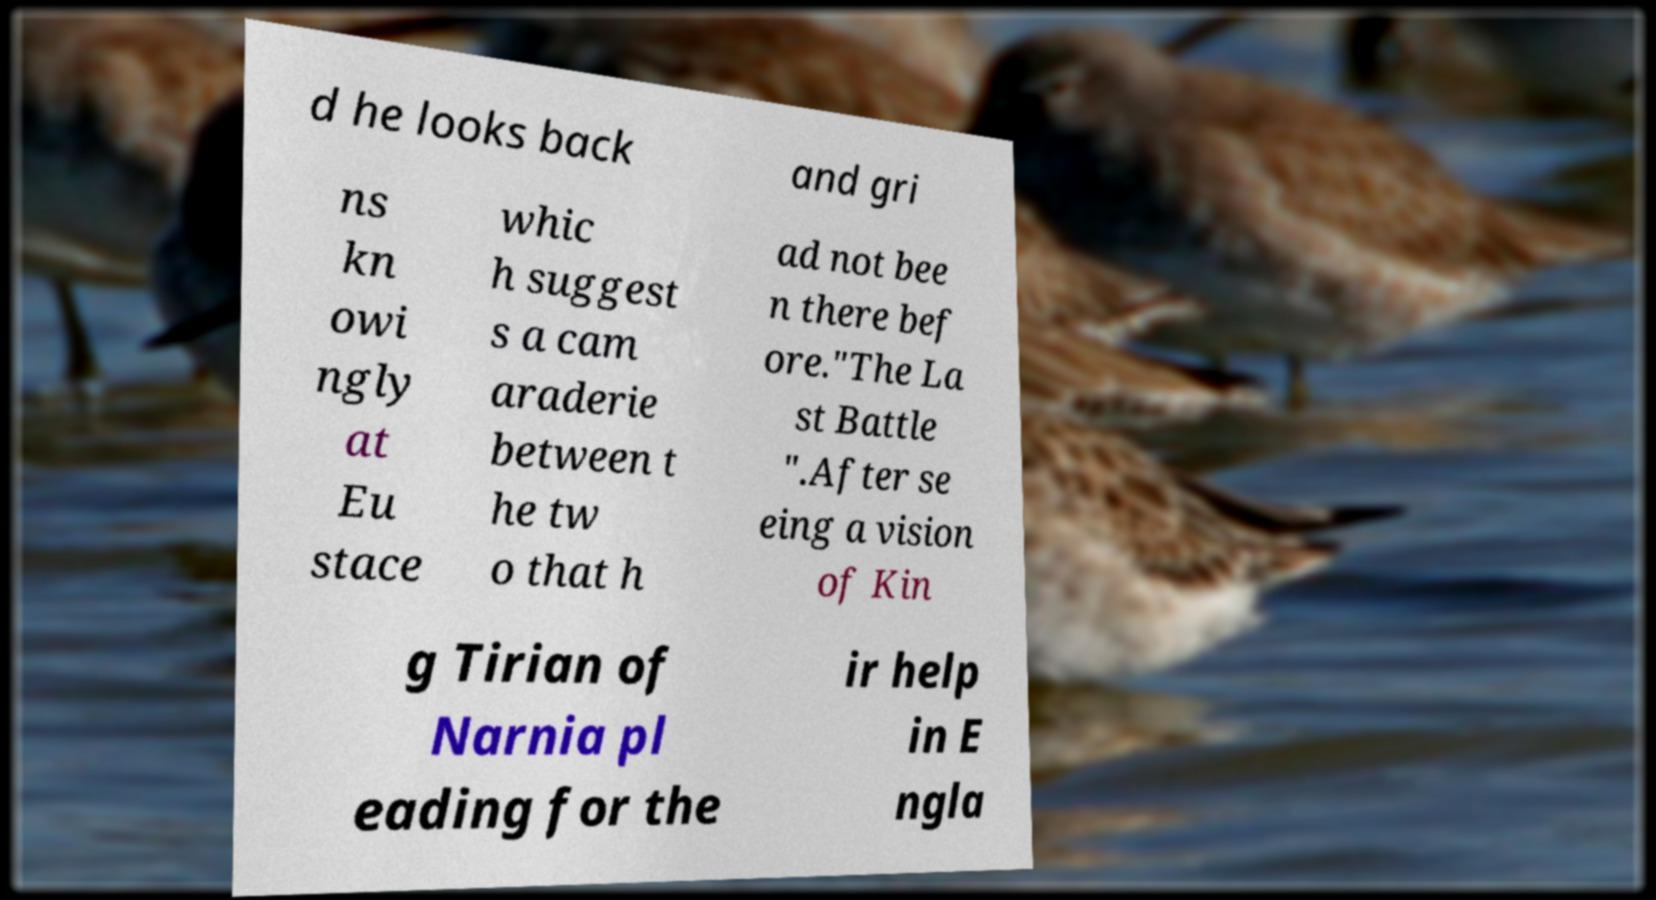Please identify and transcribe the text found in this image. d he looks back and gri ns kn owi ngly at Eu stace whic h suggest s a cam araderie between t he tw o that h ad not bee n there bef ore."The La st Battle ".After se eing a vision of Kin g Tirian of Narnia pl eading for the ir help in E ngla 